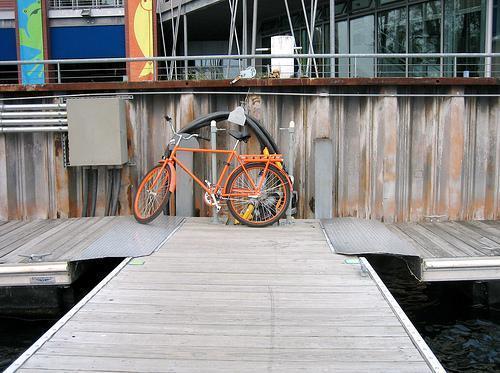How many bikes are shown?
Give a very brief answer. 1. 